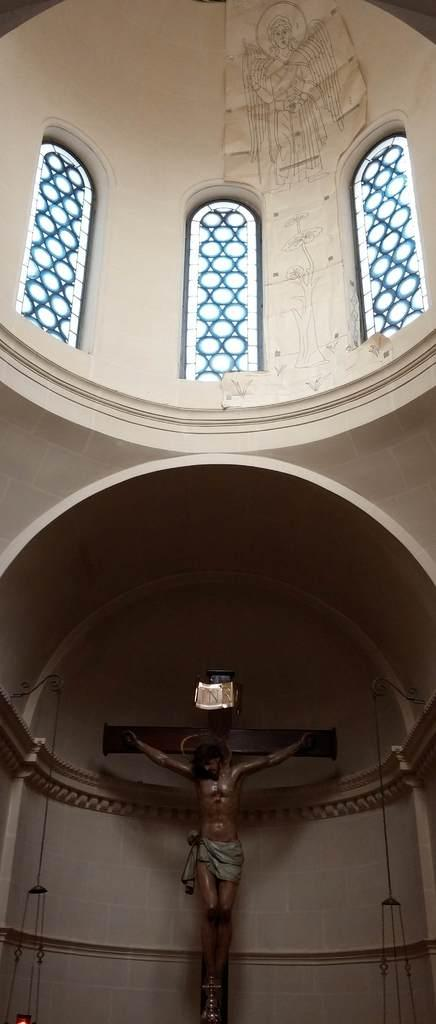What type of building is depicted in the image? The image shows an inside view of a church. What architectural features can be seen in the church? There are windows and a wall with a design in the church. What objects are present in the church? There is a statue and a stand in the church. What type of ring is being used for the performance on the stage in the image? There is no stage or ring present in the image; it shows an inside view of a church. 